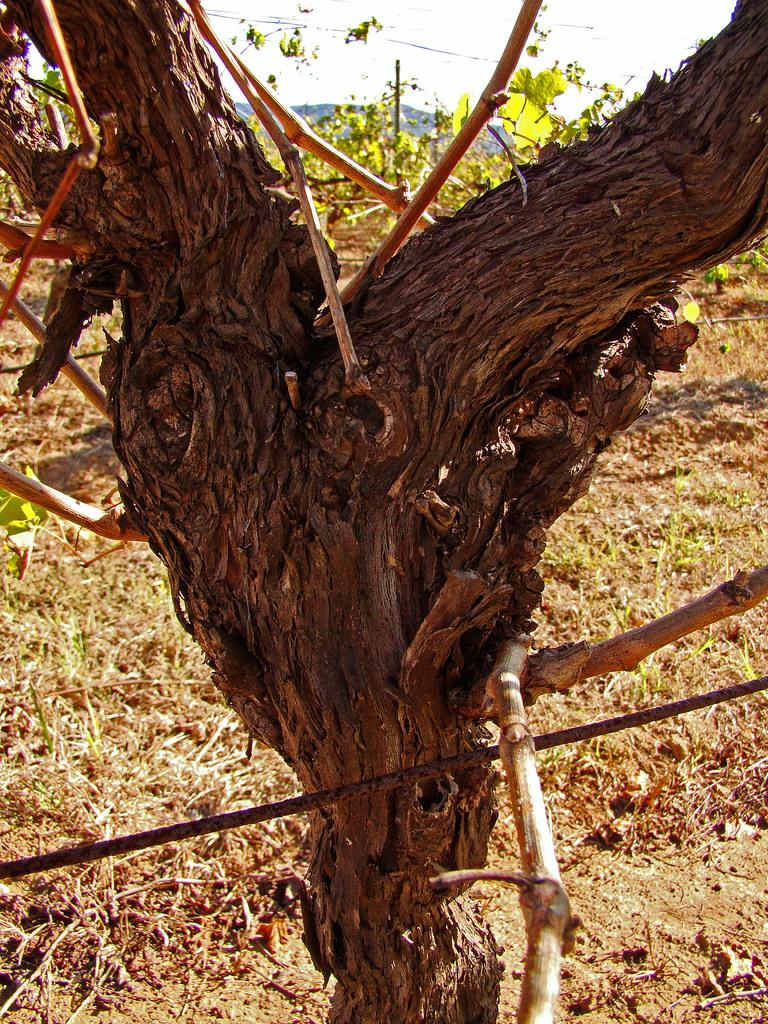What is the main object in the center of the image? There is a trunk in the center of the image. What type of slave is depicted in the image? There is no depiction of a slave in the image; it only features a trunk. What kind of drug can be seen in the image? There is no drug present in the image; it only features a trunk. 